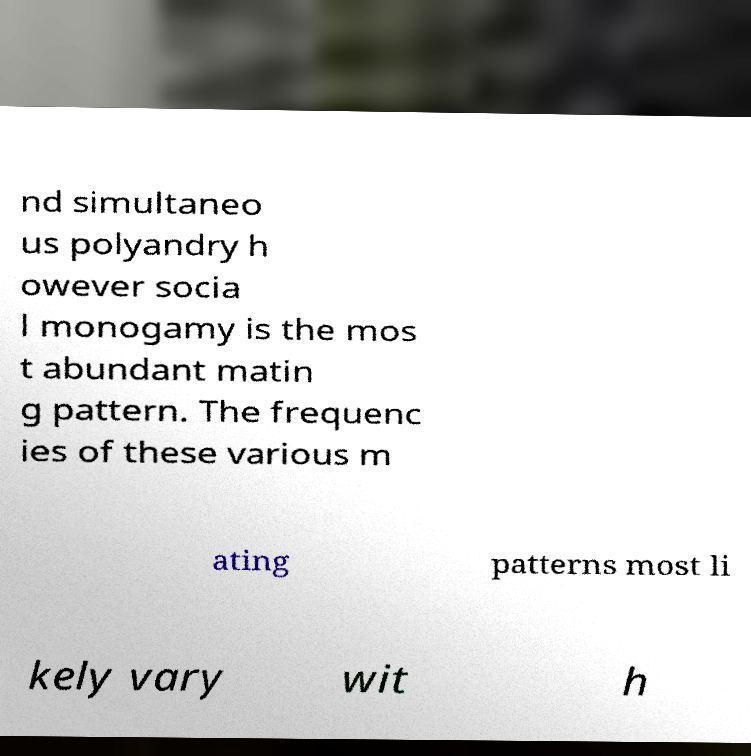What messages or text are displayed in this image? I need them in a readable, typed format. nd simultaneo us polyandry h owever socia l monogamy is the mos t abundant matin g pattern. The frequenc ies of these various m ating patterns most li kely vary wit h 